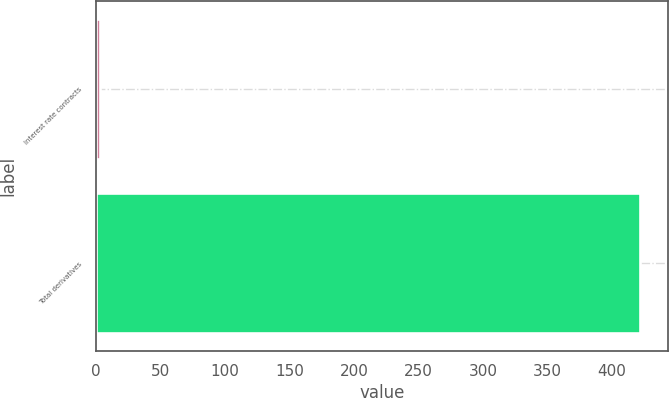Convert chart. <chart><loc_0><loc_0><loc_500><loc_500><bar_chart><fcel>Interest rate contracts<fcel>Total derivatives<nl><fcel>3<fcel>422<nl></chart> 